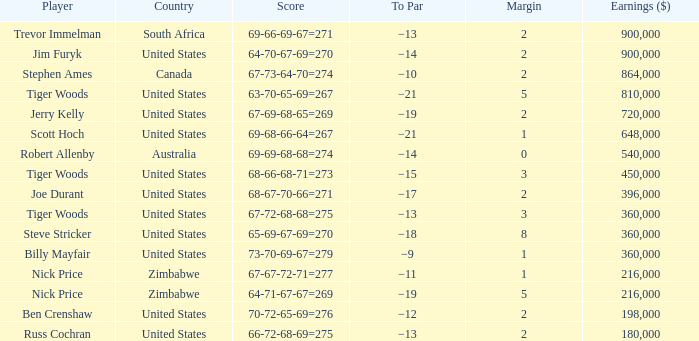Which To Par has Earnings ($) larger than 360,000, and a Year larger than 1998, and a Country of united states, and a Score of 69-68-66-64=267? −21. 